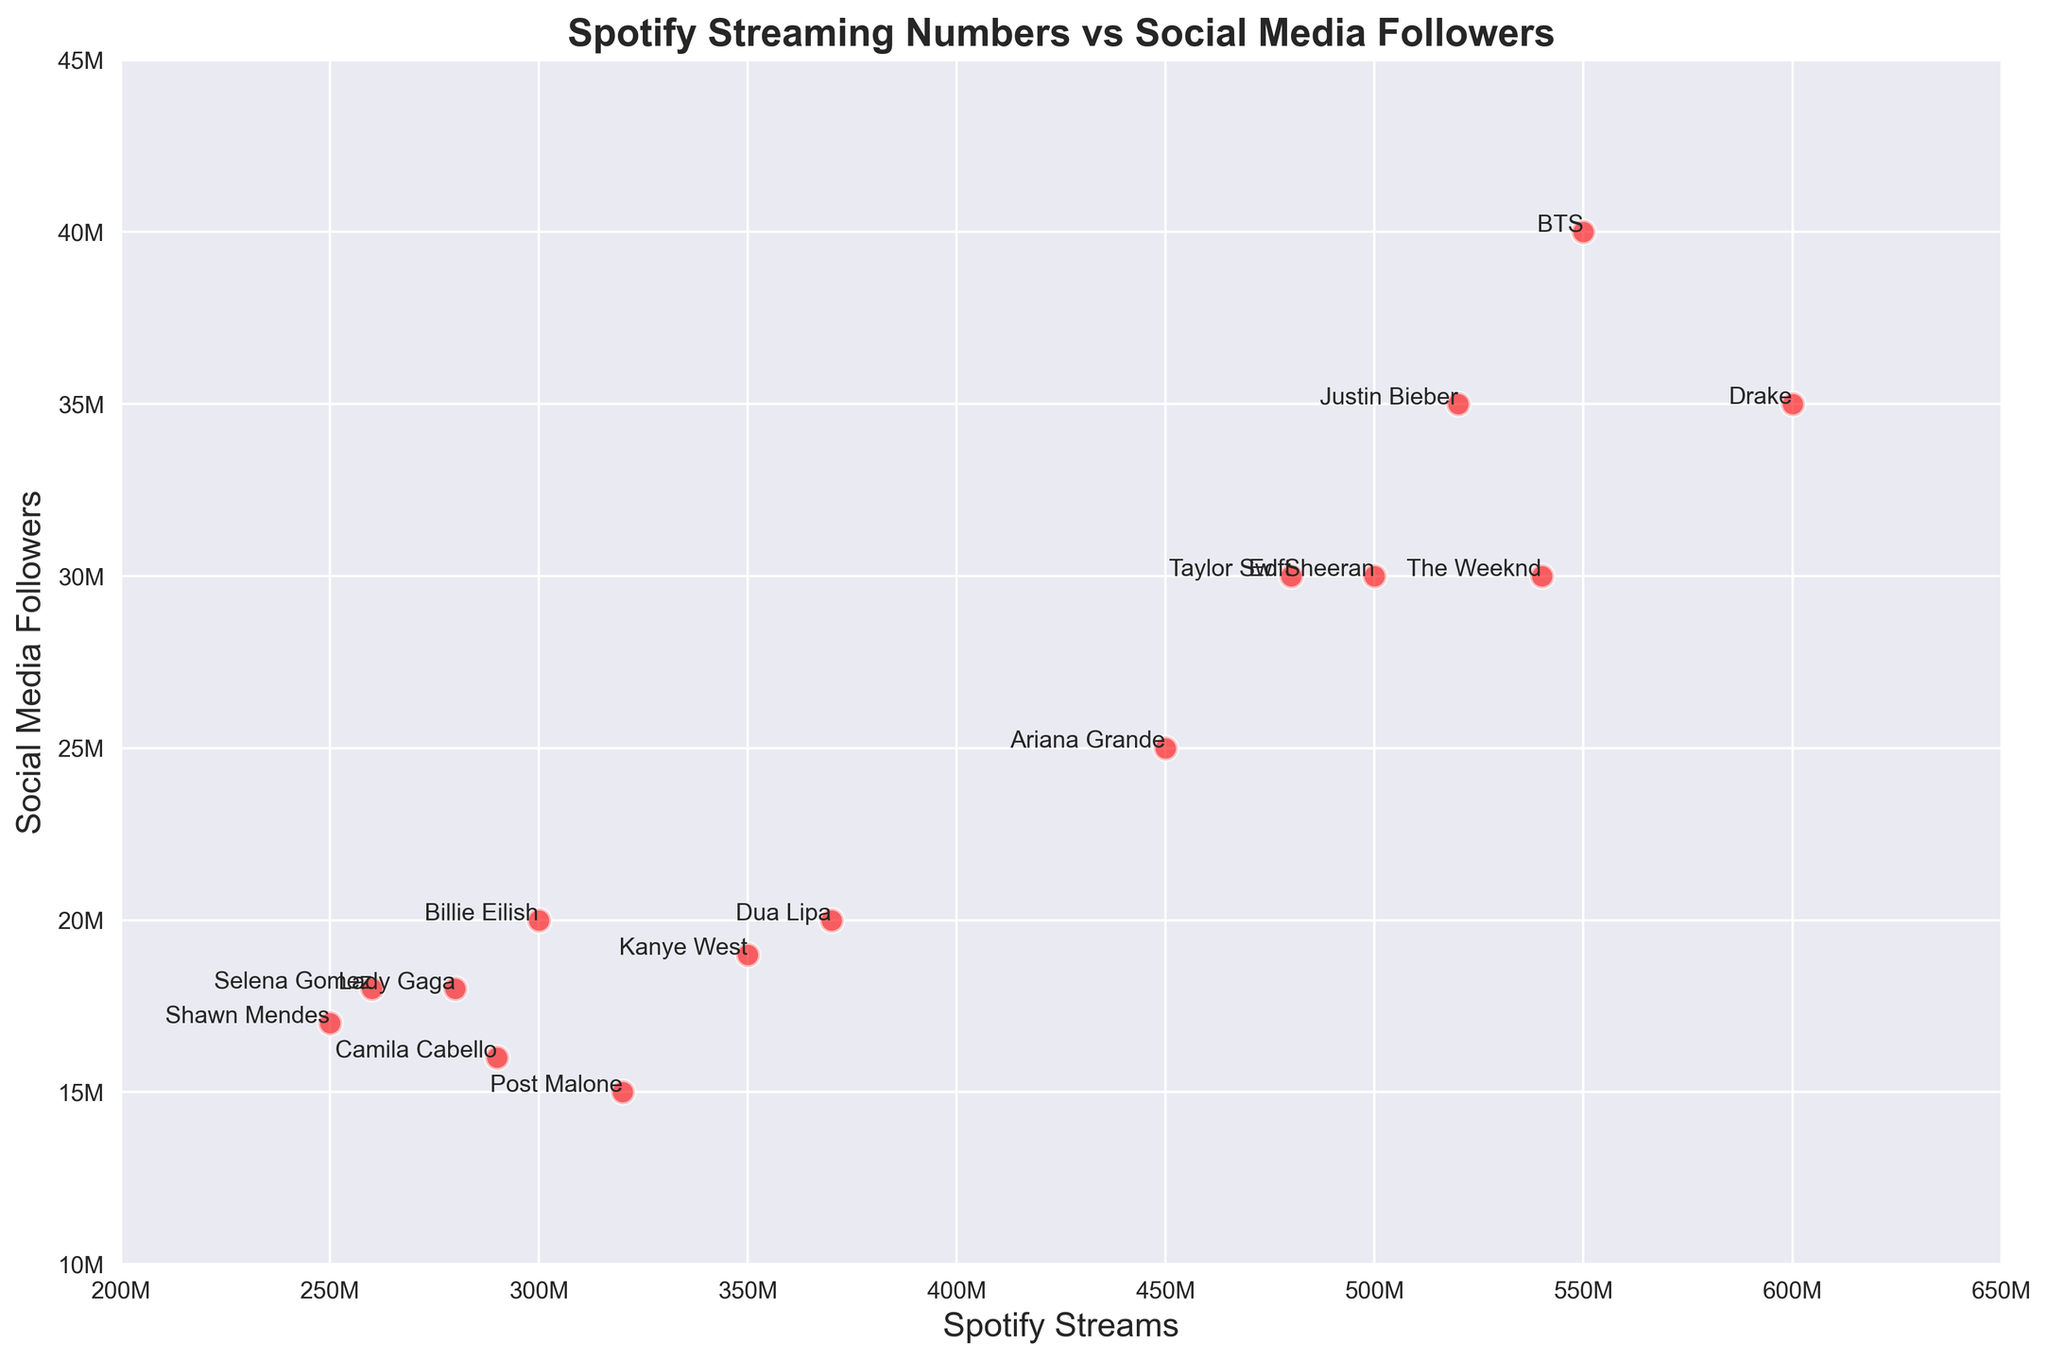Which artist has the highest number of Spotify streams? By looking at the scatter plot, find the point that is farthest to the right on the x-axis which represents Spotify streams. The artist at this point is Drake.
Answer: Drake How many artists have social media followers between 20M and 30M? Count the number of points that lie between 20 million and 30 million on the y-axis. The artists within this range are Billie Eilish, Taylor Swift, The Weeknd, Lady Gaga, Selena Gomez, and Kanye West.
Answer: 6 Which artist has more Spotify streams: Ariana Grande or BTS? Compare the positions of the points for Ariana Grande and BTS on the x-axis. BTS is positioned farther right, indicating a higher number of Spotify streams.
Answer: BTS What is the average number of social media followers for Shawn Mendes and Camila Cabello? Add the social media followers of Shawn Mendes and Camila Cabello, then divide by 2. Shawn Mendes has 17 million, and Camila Cabello has 16 million. So, (17M + 16M) / 2 = 16.5M.
Answer: 16.5M Which artist has the lowest number of Spotify streams among those with more than 30M social media followers? Identify the points with social media followers more than 30 million. Among these points, find the one with the lowest Spotify streams by looking down towards the x-axis. This artist is Ed Sheeran.
Answer: Ed Sheeran How many artists have both Spotify streams above 400M and social media followers above 25M? Look for points that meet both criteria: more than 400 million Spotify streams and more than 25 million social media followers. These artists are Ed Sheeran, Ariana Grande, Drake, BTS, Taylor Swift, Justin Bieber, and The Weeknd.
Answer: 7 Do Lady Gaga and Selena Gomez have the same number of social media followers? Check the y-axis positions of Lady Gaga and Selena Gomez. Both are at 18 million followers.
Answer: Yes Who has more social media followers: Post Malone or Kanye West? Compare the positions of the points for Post Malone and Kanye West on the y-axis. Kanye West is positioned higher, indicating more social media followers.
Answer: Kanye West What is the difference in Spotify streams between Billie Eilish and Dua Lipa? Find the positions of Billie Eilish and Dua Lipa on the x-axis and subtract Dua Lipa's Spotify streams from Billie Eilish's. Billie Eilish has 300M, and Dua Lipa has 370M, so the difference is 370M - 300M = 70M.
Answer: 70M 